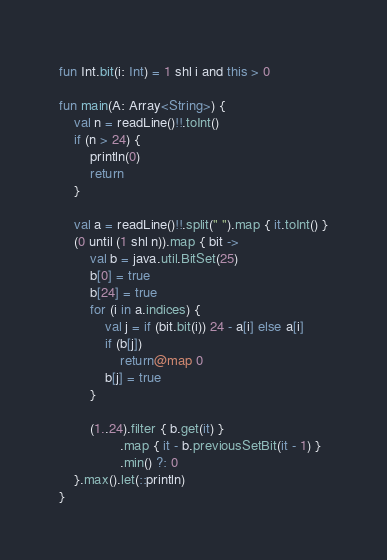<code> <loc_0><loc_0><loc_500><loc_500><_Kotlin_>fun Int.bit(i: Int) = 1 shl i and this > 0

fun main(A: Array<String>) {
    val n = readLine()!!.toInt()
    if (n > 24) {
        println(0)
        return
    }

    val a = readLine()!!.split(" ").map { it.toInt() }
    (0 until (1 shl n)).map { bit ->
        val b = java.util.BitSet(25)
        b[0] = true
        b[24] = true
        for (i in a.indices) {
            val j = if (bit.bit(i)) 24 - a[i] else a[i]
            if (b[j])
                return@map 0
            b[j] = true
        }

        (1..24).filter { b.get(it) }
                .map { it - b.previousSetBit(it - 1) }
                .min() ?: 0
    }.max().let(::println)
}
</code> 